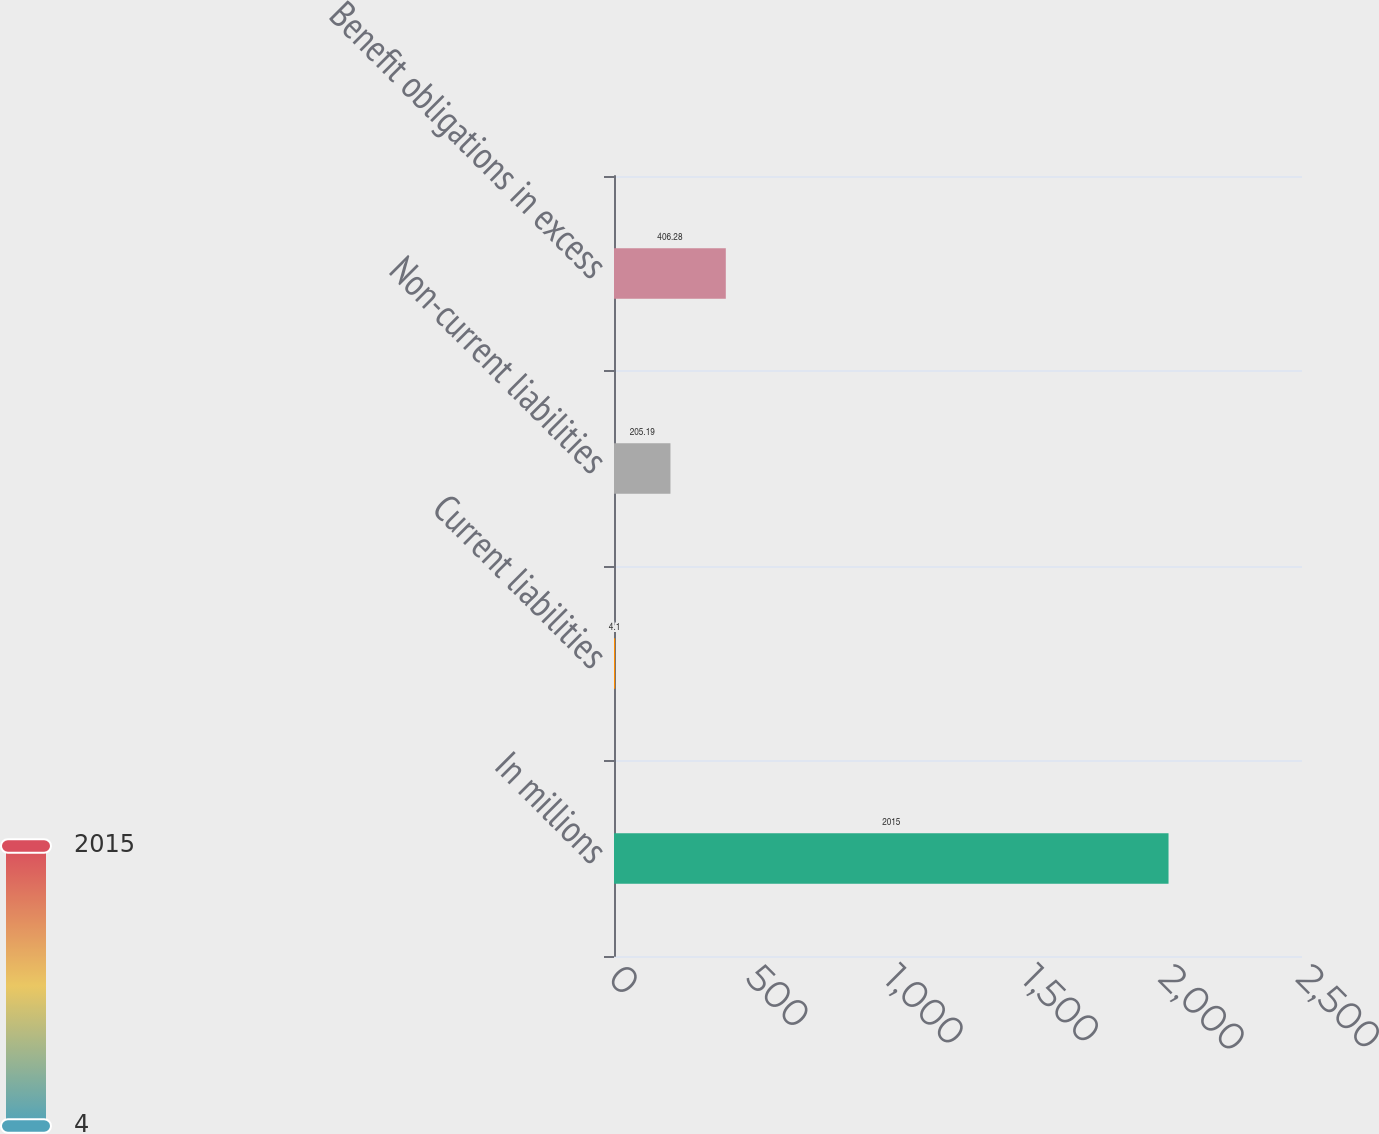<chart> <loc_0><loc_0><loc_500><loc_500><bar_chart><fcel>In millions<fcel>Current liabilities<fcel>Non-current liabilities<fcel>Benefit obligations in excess<nl><fcel>2015<fcel>4.1<fcel>205.19<fcel>406.28<nl></chart> 